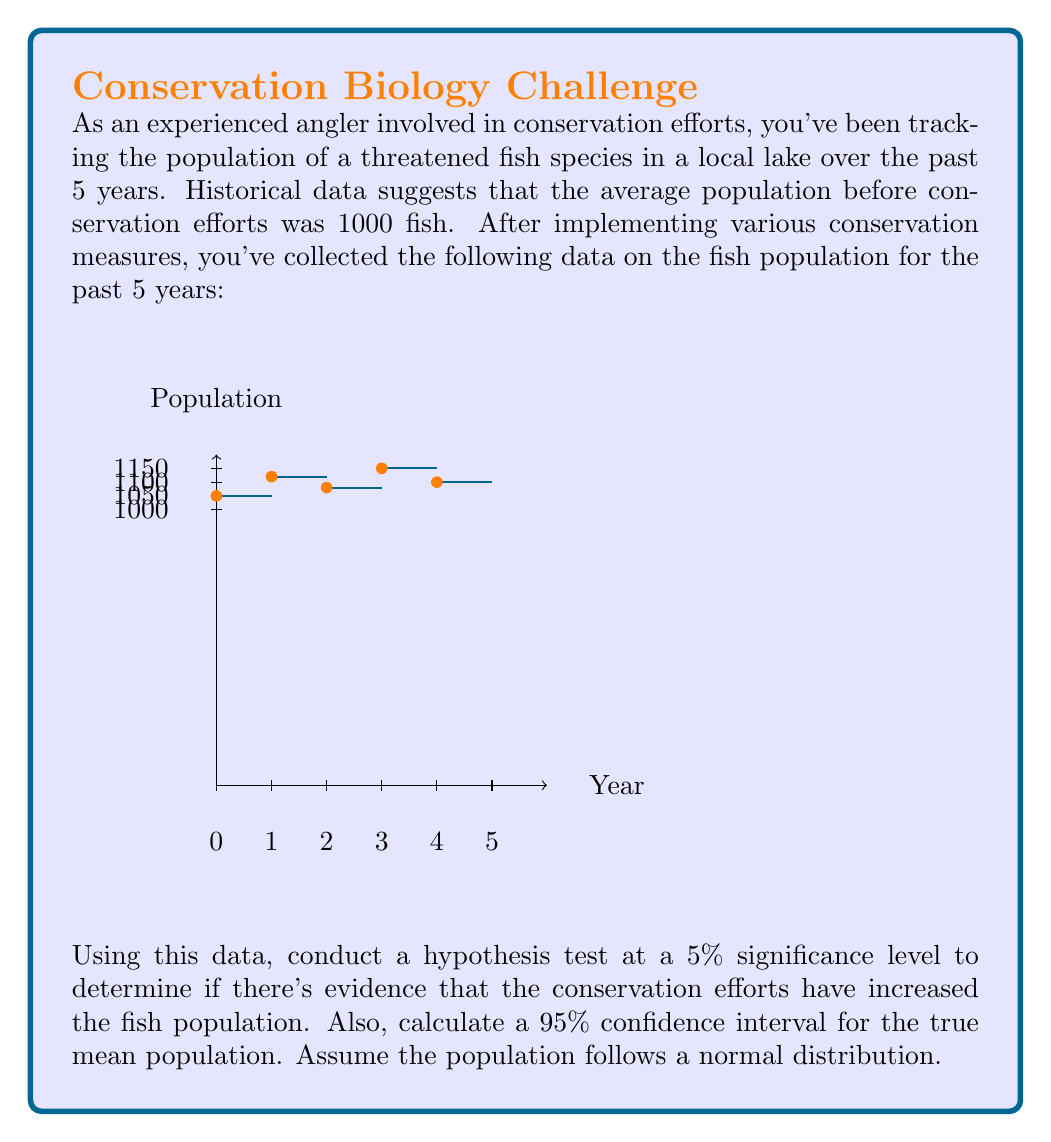Teach me how to tackle this problem. Let's approach this step-by-step:

1) First, we need to calculate the sample mean and standard deviation:

   Sample mean: $\bar{x} = \frac{1050 + 1120 + 1080 + 1150 + 1100}{5} = 1100$
   
   Sample standard deviation: 
   $s = \sqrt{\frac{\sum(x_i - \bar{x})^2}{n-1}} = \sqrt{\frac{10000}{4}} = 50$

2) For the hypothesis test:
   $H_0: \mu = 1000$ (null hypothesis)
   $H_a: \mu > 1000$ (alternative hypothesis, one-tailed test)

3) Calculate the t-statistic:
   $t = \frac{\bar{x} - \mu_0}{s/\sqrt{n}} = \frac{1100 - 1000}{50/\sqrt{5}} = 4.47$

4) For a 5% significance level and 4 degrees of freedom, the critical t-value is 2.132.

5) Since 4.47 > 2.132, we reject the null hypothesis. There is evidence that conservation efforts have increased the fish population.

6) For the 95% confidence interval:
   $CI = \bar{x} \pm t_{\alpha/2, n-1} \cdot \frac{s}{\sqrt{n}}$
   
   Where $t_{\alpha/2, n-1} = t_{0.025, 4} = 2.776$

   $CI = 1100 \pm 2.776 \cdot \frac{50}{\sqrt{5}} = 1100 \pm 61.95$

   So, the 95% confidence interval is (1038.05, 1161.95)
Answer: Reject $H_0$; 95% CI: (1038.05, 1161.95) 